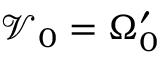Convert formula to latex. <formula><loc_0><loc_0><loc_500><loc_500>\mathcal { V } _ { 0 } = \Omega _ { 0 } ^ { \prime }</formula> 